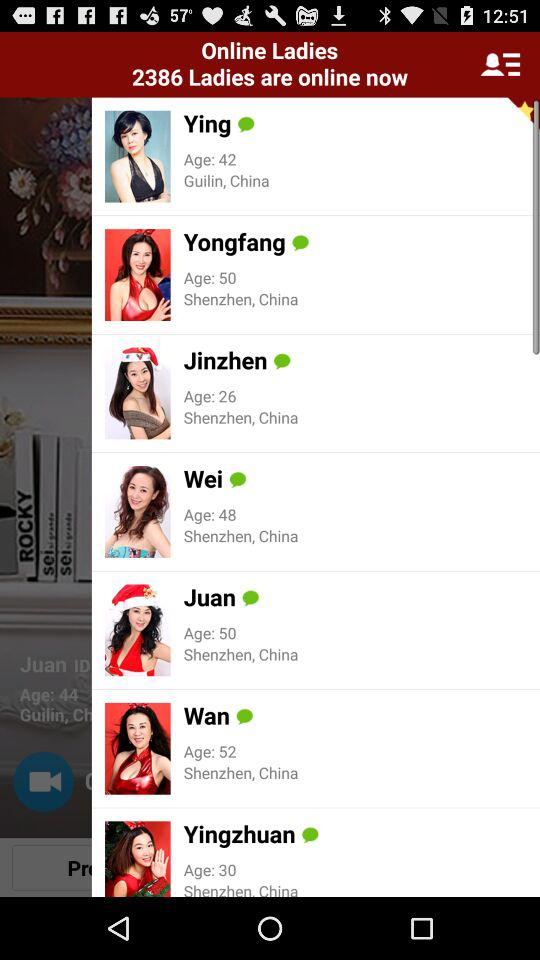What is the mentioned location of Juan? The mentioned location is Shenzhen, China. 